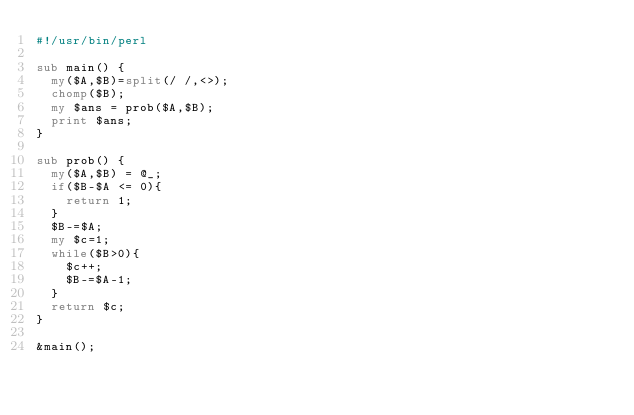Convert code to text. <code><loc_0><loc_0><loc_500><loc_500><_Perl_>#!/usr/bin/perl

sub main() {
  my($A,$B)=split(/ /,<>);
  chomp($B);
  my $ans = prob($A,$B);
  print $ans;
}

sub prob() {
  my($A,$B) = @_;
  if($B-$A <= 0){
    return 1;
  }
  $B-=$A;
  my $c=1;
  while($B>0){
    $c++;
    $B-=$A-1;
  }
  return $c;
}

&main();</code> 